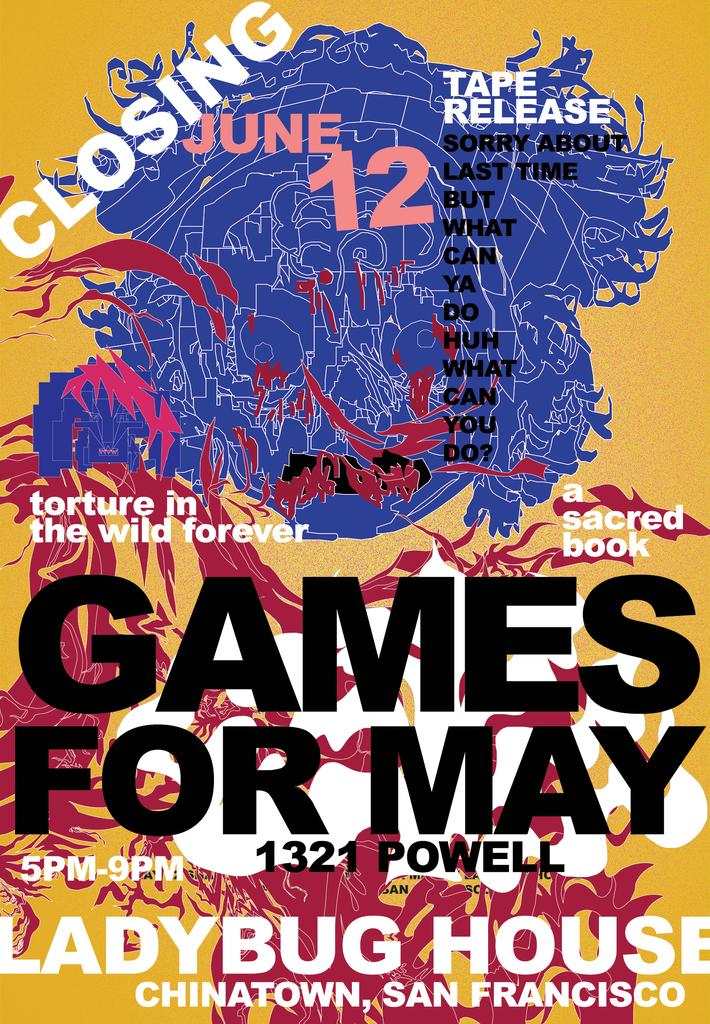<image>
Create a compact narrative representing the image presented. Poster for Games for May that takes place on Powell street. 